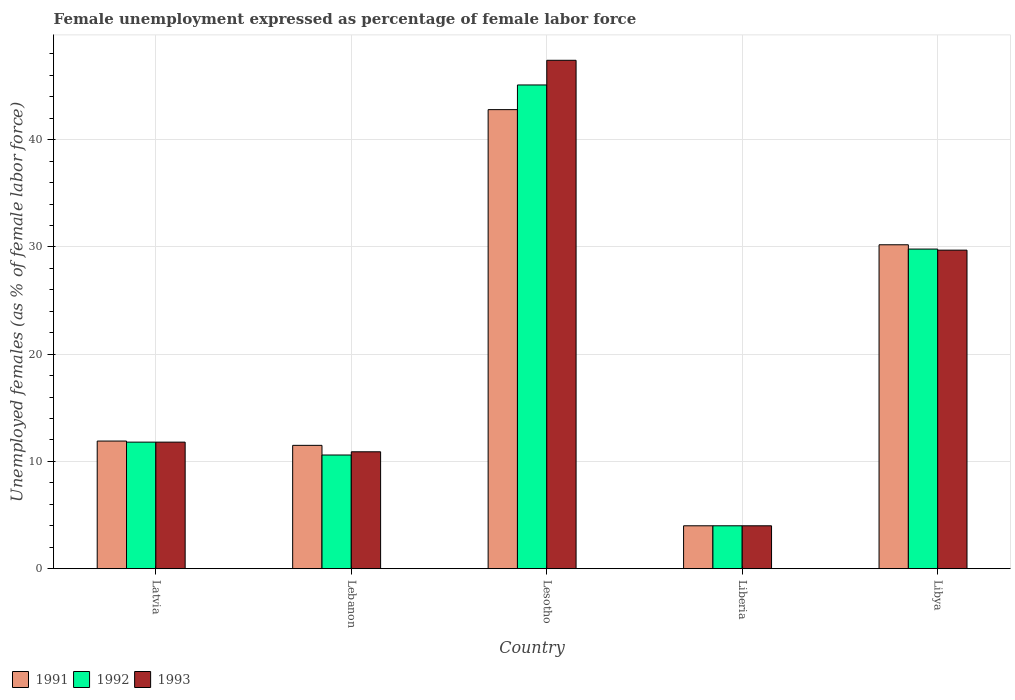How many different coloured bars are there?
Keep it short and to the point. 3. How many groups of bars are there?
Provide a succinct answer. 5. Are the number of bars per tick equal to the number of legend labels?
Your answer should be very brief. Yes. Are the number of bars on each tick of the X-axis equal?
Keep it short and to the point. Yes. How many bars are there on the 2nd tick from the right?
Keep it short and to the point. 3. What is the label of the 2nd group of bars from the left?
Offer a terse response. Lebanon. In how many cases, is the number of bars for a given country not equal to the number of legend labels?
Keep it short and to the point. 0. Across all countries, what is the maximum unemployment in females in in 1993?
Keep it short and to the point. 47.4. In which country was the unemployment in females in in 1991 maximum?
Provide a short and direct response. Lesotho. In which country was the unemployment in females in in 1991 minimum?
Offer a terse response. Liberia. What is the total unemployment in females in in 1992 in the graph?
Your answer should be very brief. 101.3. What is the difference between the unemployment in females in in 1992 in Latvia and that in Liberia?
Make the answer very short. 7.8. What is the difference between the unemployment in females in in 1993 in Lebanon and the unemployment in females in in 1992 in Latvia?
Give a very brief answer. -0.9. What is the average unemployment in females in in 1993 per country?
Your response must be concise. 20.76. In how many countries, is the unemployment in females in in 1991 greater than 18 %?
Provide a short and direct response. 2. What is the ratio of the unemployment in females in in 1993 in Latvia to that in Liberia?
Make the answer very short. 2.95. Is the unemployment in females in in 1993 in Latvia less than that in Liberia?
Your response must be concise. No. What is the difference between the highest and the second highest unemployment in females in in 1993?
Make the answer very short. -17.9. What is the difference between the highest and the lowest unemployment in females in in 1993?
Offer a terse response. 43.4. In how many countries, is the unemployment in females in in 1993 greater than the average unemployment in females in in 1993 taken over all countries?
Offer a terse response. 2. Is the sum of the unemployment in females in in 1992 in Latvia and Libya greater than the maximum unemployment in females in in 1991 across all countries?
Provide a succinct answer. No. What does the 1st bar from the left in Libya represents?
Offer a very short reply. 1991. What does the 3rd bar from the right in Lebanon represents?
Keep it short and to the point. 1991. Is it the case that in every country, the sum of the unemployment in females in in 1991 and unemployment in females in in 1992 is greater than the unemployment in females in in 1993?
Your answer should be very brief. Yes. How many bars are there?
Your answer should be very brief. 15. Are all the bars in the graph horizontal?
Ensure brevity in your answer.  No. How many countries are there in the graph?
Give a very brief answer. 5. Does the graph contain any zero values?
Your answer should be very brief. No. How are the legend labels stacked?
Your answer should be compact. Horizontal. What is the title of the graph?
Give a very brief answer. Female unemployment expressed as percentage of female labor force. What is the label or title of the Y-axis?
Make the answer very short. Unemployed females (as % of female labor force). What is the Unemployed females (as % of female labor force) in 1991 in Latvia?
Make the answer very short. 11.9. What is the Unemployed females (as % of female labor force) of 1992 in Latvia?
Offer a very short reply. 11.8. What is the Unemployed females (as % of female labor force) in 1993 in Latvia?
Ensure brevity in your answer.  11.8. What is the Unemployed females (as % of female labor force) of 1992 in Lebanon?
Provide a succinct answer. 10.6. What is the Unemployed females (as % of female labor force) in 1993 in Lebanon?
Offer a very short reply. 10.9. What is the Unemployed females (as % of female labor force) of 1991 in Lesotho?
Ensure brevity in your answer.  42.8. What is the Unemployed females (as % of female labor force) of 1992 in Lesotho?
Provide a short and direct response. 45.1. What is the Unemployed females (as % of female labor force) in 1993 in Lesotho?
Ensure brevity in your answer.  47.4. What is the Unemployed females (as % of female labor force) in 1991 in Liberia?
Offer a terse response. 4. What is the Unemployed females (as % of female labor force) in 1992 in Liberia?
Offer a terse response. 4. What is the Unemployed females (as % of female labor force) of 1993 in Liberia?
Keep it short and to the point. 4. What is the Unemployed females (as % of female labor force) of 1991 in Libya?
Ensure brevity in your answer.  30.2. What is the Unemployed females (as % of female labor force) in 1992 in Libya?
Keep it short and to the point. 29.8. What is the Unemployed females (as % of female labor force) in 1993 in Libya?
Offer a very short reply. 29.7. Across all countries, what is the maximum Unemployed females (as % of female labor force) of 1991?
Provide a succinct answer. 42.8. Across all countries, what is the maximum Unemployed females (as % of female labor force) of 1992?
Give a very brief answer. 45.1. Across all countries, what is the maximum Unemployed females (as % of female labor force) of 1993?
Give a very brief answer. 47.4. Across all countries, what is the minimum Unemployed females (as % of female labor force) in 1991?
Your answer should be very brief. 4. Across all countries, what is the minimum Unemployed females (as % of female labor force) of 1992?
Your answer should be very brief. 4. What is the total Unemployed females (as % of female labor force) of 1991 in the graph?
Your answer should be very brief. 100.4. What is the total Unemployed females (as % of female labor force) of 1992 in the graph?
Make the answer very short. 101.3. What is the total Unemployed females (as % of female labor force) of 1993 in the graph?
Give a very brief answer. 103.8. What is the difference between the Unemployed females (as % of female labor force) in 1991 in Latvia and that in Lebanon?
Make the answer very short. 0.4. What is the difference between the Unemployed females (as % of female labor force) of 1992 in Latvia and that in Lebanon?
Provide a short and direct response. 1.2. What is the difference between the Unemployed females (as % of female labor force) of 1991 in Latvia and that in Lesotho?
Offer a terse response. -30.9. What is the difference between the Unemployed females (as % of female labor force) of 1992 in Latvia and that in Lesotho?
Keep it short and to the point. -33.3. What is the difference between the Unemployed females (as % of female labor force) in 1993 in Latvia and that in Lesotho?
Give a very brief answer. -35.6. What is the difference between the Unemployed females (as % of female labor force) in 1993 in Latvia and that in Liberia?
Make the answer very short. 7.8. What is the difference between the Unemployed females (as % of female labor force) of 1991 in Latvia and that in Libya?
Your answer should be compact. -18.3. What is the difference between the Unemployed females (as % of female labor force) in 1992 in Latvia and that in Libya?
Keep it short and to the point. -18. What is the difference between the Unemployed females (as % of female labor force) of 1993 in Latvia and that in Libya?
Provide a succinct answer. -17.9. What is the difference between the Unemployed females (as % of female labor force) in 1991 in Lebanon and that in Lesotho?
Ensure brevity in your answer.  -31.3. What is the difference between the Unemployed females (as % of female labor force) of 1992 in Lebanon and that in Lesotho?
Provide a short and direct response. -34.5. What is the difference between the Unemployed females (as % of female labor force) of 1993 in Lebanon and that in Lesotho?
Offer a very short reply. -36.5. What is the difference between the Unemployed females (as % of female labor force) in 1993 in Lebanon and that in Liberia?
Your response must be concise. 6.9. What is the difference between the Unemployed females (as % of female labor force) of 1991 in Lebanon and that in Libya?
Provide a short and direct response. -18.7. What is the difference between the Unemployed females (as % of female labor force) in 1992 in Lebanon and that in Libya?
Provide a succinct answer. -19.2. What is the difference between the Unemployed females (as % of female labor force) in 1993 in Lebanon and that in Libya?
Provide a short and direct response. -18.8. What is the difference between the Unemployed females (as % of female labor force) in 1991 in Lesotho and that in Liberia?
Provide a short and direct response. 38.8. What is the difference between the Unemployed females (as % of female labor force) of 1992 in Lesotho and that in Liberia?
Offer a very short reply. 41.1. What is the difference between the Unemployed females (as % of female labor force) of 1993 in Lesotho and that in Liberia?
Ensure brevity in your answer.  43.4. What is the difference between the Unemployed females (as % of female labor force) in 1991 in Lesotho and that in Libya?
Your response must be concise. 12.6. What is the difference between the Unemployed females (as % of female labor force) of 1993 in Lesotho and that in Libya?
Ensure brevity in your answer.  17.7. What is the difference between the Unemployed females (as % of female labor force) in 1991 in Liberia and that in Libya?
Give a very brief answer. -26.2. What is the difference between the Unemployed females (as % of female labor force) in 1992 in Liberia and that in Libya?
Give a very brief answer. -25.8. What is the difference between the Unemployed females (as % of female labor force) in 1993 in Liberia and that in Libya?
Your response must be concise. -25.7. What is the difference between the Unemployed females (as % of female labor force) in 1992 in Latvia and the Unemployed females (as % of female labor force) in 1993 in Lebanon?
Your response must be concise. 0.9. What is the difference between the Unemployed females (as % of female labor force) of 1991 in Latvia and the Unemployed females (as % of female labor force) of 1992 in Lesotho?
Offer a very short reply. -33.2. What is the difference between the Unemployed females (as % of female labor force) of 1991 in Latvia and the Unemployed females (as % of female labor force) of 1993 in Lesotho?
Your answer should be very brief. -35.5. What is the difference between the Unemployed females (as % of female labor force) in 1992 in Latvia and the Unemployed females (as % of female labor force) in 1993 in Lesotho?
Your answer should be very brief. -35.6. What is the difference between the Unemployed females (as % of female labor force) of 1991 in Latvia and the Unemployed females (as % of female labor force) of 1993 in Liberia?
Offer a terse response. 7.9. What is the difference between the Unemployed females (as % of female labor force) in 1991 in Latvia and the Unemployed females (as % of female labor force) in 1992 in Libya?
Make the answer very short. -17.9. What is the difference between the Unemployed females (as % of female labor force) in 1991 in Latvia and the Unemployed females (as % of female labor force) in 1993 in Libya?
Your response must be concise. -17.8. What is the difference between the Unemployed females (as % of female labor force) in 1992 in Latvia and the Unemployed females (as % of female labor force) in 1993 in Libya?
Make the answer very short. -17.9. What is the difference between the Unemployed females (as % of female labor force) in 1991 in Lebanon and the Unemployed females (as % of female labor force) in 1992 in Lesotho?
Make the answer very short. -33.6. What is the difference between the Unemployed females (as % of female labor force) in 1991 in Lebanon and the Unemployed females (as % of female labor force) in 1993 in Lesotho?
Offer a terse response. -35.9. What is the difference between the Unemployed females (as % of female labor force) of 1992 in Lebanon and the Unemployed females (as % of female labor force) of 1993 in Lesotho?
Offer a terse response. -36.8. What is the difference between the Unemployed females (as % of female labor force) in 1991 in Lebanon and the Unemployed females (as % of female labor force) in 1992 in Liberia?
Ensure brevity in your answer.  7.5. What is the difference between the Unemployed females (as % of female labor force) of 1991 in Lebanon and the Unemployed females (as % of female labor force) of 1993 in Liberia?
Make the answer very short. 7.5. What is the difference between the Unemployed females (as % of female labor force) of 1991 in Lebanon and the Unemployed females (as % of female labor force) of 1992 in Libya?
Provide a short and direct response. -18.3. What is the difference between the Unemployed females (as % of female labor force) of 1991 in Lebanon and the Unemployed females (as % of female labor force) of 1993 in Libya?
Keep it short and to the point. -18.2. What is the difference between the Unemployed females (as % of female labor force) of 1992 in Lebanon and the Unemployed females (as % of female labor force) of 1993 in Libya?
Your answer should be very brief. -19.1. What is the difference between the Unemployed females (as % of female labor force) in 1991 in Lesotho and the Unemployed females (as % of female labor force) in 1992 in Liberia?
Give a very brief answer. 38.8. What is the difference between the Unemployed females (as % of female labor force) in 1991 in Lesotho and the Unemployed females (as % of female labor force) in 1993 in Liberia?
Make the answer very short. 38.8. What is the difference between the Unemployed females (as % of female labor force) of 1992 in Lesotho and the Unemployed females (as % of female labor force) of 1993 in Liberia?
Offer a very short reply. 41.1. What is the difference between the Unemployed females (as % of female labor force) in 1991 in Lesotho and the Unemployed females (as % of female labor force) in 1993 in Libya?
Provide a short and direct response. 13.1. What is the difference between the Unemployed females (as % of female labor force) in 1992 in Lesotho and the Unemployed females (as % of female labor force) in 1993 in Libya?
Your answer should be compact. 15.4. What is the difference between the Unemployed females (as % of female labor force) in 1991 in Liberia and the Unemployed females (as % of female labor force) in 1992 in Libya?
Provide a short and direct response. -25.8. What is the difference between the Unemployed females (as % of female labor force) in 1991 in Liberia and the Unemployed females (as % of female labor force) in 1993 in Libya?
Ensure brevity in your answer.  -25.7. What is the difference between the Unemployed females (as % of female labor force) in 1992 in Liberia and the Unemployed females (as % of female labor force) in 1993 in Libya?
Ensure brevity in your answer.  -25.7. What is the average Unemployed females (as % of female labor force) in 1991 per country?
Provide a succinct answer. 20.08. What is the average Unemployed females (as % of female labor force) in 1992 per country?
Offer a very short reply. 20.26. What is the average Unemployed females (as % of female labor force) of 1993 per country?
Offer a very short reply. 20.76. What is the difference between the Unemployed females (as % of female labor force) in 1991 and Unemployed females (as % of female labor force) in 1992 in Latvia?
Offer a very short reply. 0.1. What is the difference between the Unemployed females (as % of female labor force) of 1992 and Unemployed females (as % of female labor force) of 1993 in Latvia?
Offer a terse response. 0. What is the difference between the Unemployed females (as % of female labor force) of 1991 and Unemployed females (as % of female labor force) of 1992 in Lebanon?
Offer a terse response. 0.9. What is the difference between the Unemployed females (as % of female labor force) in 1991 and Unemployed females (as % of female labor force) in 1993 in Lebanon?
Offer a terse response. 0.6. What is the difference between the Unemployed females (as % of female labor force) in 1991 and Unemployed females (as % of female labor force) in 1992 in Lesotho?
Your response must be concise. -2.3. What is the difference between the Unemployed females (as % of female labor force) of 1992 and Unemployed females (as % of female labor force) of 1993 in Lesotho?
Keep it short and to the point. -2.3. What is the difference between the Unemployed females (as % of female labor force) of 1991 and Unemployed females (as % of female labor force) of 1992 in Liberia?
Provide a short and direct response. 0. What is the difference between the Unemployed females (as % of female labor force) of 1991 and Unemployed females (as % of female labor force) of 1993 in Liberia?
Offer a very short reply. 0. What is the difference between the Unemployed females (as % of female labor force) of 1992 and Unemployed females (as % of female labor force) of 1993 in Liberia?
Keep it short and to the point. 0. What is the difference between the Unemployed females (as % of female labor force) in 1991 and Unemployed females (as % of female labor force) in 1992 in Libya?
Ensure brevity in your answer.  0.4. What is the difference between the Unemployed females (as % of female labor force) in 1991 and Unemployed females (as % of female labor force) in 1993 in Libya?
Make the answer very short. 0.5. What is the difference between the Unemployed females (as % of female labor force) in 1992 and Unemployed females (as % of female labor force) in 1993 in Libya?
Your answer should be compact. 0.1. What is the ratio of the Unemployed females (as % of female labor force) in 1991 in Latvia to that in Lebanon?
Keep it short and to the point. 1.03. What is the ratio of the Unemployed females (as % of female labor force) in 1992 in Latvia to that in Lebanon?
Ensure brevity in your answer.  1.11. What is the ratio of the Unemployed females (as % of female labor force) in 1993 in Latvia to that in Lebanon?
Provide a short and direct response. 1.08. What is the ratio of the Unemployed females (as % of female labor force) of 1991 in Latvia to that in Lesotho?
Provide a short and direct response. 0.28. What is the ratio of the Unemployed females (as % of female labor force) in 1992 in Latvia to that in Lesotho?
Make the answer very short. 0.26. What is the ratio of the Unemployed females (as % of female labor force) of 1993 in Latvia to that in Lesotho?
Ensure brevity in your answer.  0.25. What is the ratio of the Unemployed females (as % of female labor force) in 1991 in Latvia to that in Liberia?
Your response must be concise. 2.98. What is the ratio of the Unemployed females (as % of female labor force) in 1992 in Latvia to that in Liberia?
Give a very brief answer. 2.95. What is the ratio of the Unemployed females (as % of female labor force) in 1993 in Latvia to that in Liberia?
Provide a short and direct response. 2.95. What is the ratio of the Unemployed females (as % of female labor force) in 1991 in Latvia to that in Libya?
Offer a terse response. 0.39. What is the ratio of the Unemployed females (as % of female labor force) of 1992 in Latvia to that in Libya?
Make the answer very short. 0.4. What is the ratio of the Unemployed females (as % of female labor force) in 1993 in Latvia to that in Libya?
Your answer should be compact. 0.4. What is the ratio of the Unemployed females (as % of female labor force) in 1991 in Lebanon to that in Lesotho?
Your answer should be compact. 0.27. What is the ratio of the Unemployed females (as % of female labor force) in 1992 in Lebanon to that in Lesotho?
Offer a very short reply. 0.23. What is the ratio of the Unemployed females (as % of female labor force) of 1993 in Lebanon to that in Lesotho?
Provide a succinct answer. 0.23. What is the ratio of the Unemployed females (as % of female labor force) in 1991 in Lebanon to that in Liberia?
Give a very brief answer. 2.88. What is the ratio of the Unemployed females (as % of female labor force) in 1992 in Lebanon to that in Liberia?
Your answer should be very brief. 2.65. What is the ratio of the Unemployed females (as % of female labor force) in 1993 in Lebanon to that in Liberia?
Offer a very short reply. 2.73. What is the ratio of the Unemployed females (as % of female labor force) of 1991 in Lebanon to that in Libya?
Provide a short and direct response. 0.38. What is the ratio of the Unemployed females (as % of female labor force) of 1992 in Lebanon to that in Libya?
Your response must be concise. 0.36. What is the ratio of the Unemployed females (as % of female labor force) in 1993 in Lebanon to that in Libya?
Give a very brief answer. 0.37. What is the ratio of the Unemployed females (as % of female labor force) in 1991 in Lesotho to that in Liberia?
Give a very brief answer. 10.7. What is the ratio of the Unemployed females (as % of female labor force) in 1992 in Lesotho to that in Liberia?
Provide a succinct answer. 11.28. What is the ratio of the Unemployed females (as % of female labor force) of 1993 in Lesotho to that in Liberia?
Give a very brief answer. 11.85. What is the ratio of the Unemployed females (as % of female labor force) in 1991 in Lesotho to that in Libya?
Provide a succinct answer. 1.42. What is the ratio of the Unemployed females (as % of female labor force) of 1992 in Lesotho to that in Libya?
Make the answer very short. 1.51. What is the ratio of the Unemployed females (as % of female labor force) in 1993 in Lesotho to that in Libya?
Provide a succinct answer. 1.6. What is the ratio of the Unemployed females (as % of female labor force) of 1991 in Liberia to that in Libya?
Offer a very short reply. 0.13. What is the ratio of the Unemployed females (as % of female labor force) in 1992 in Liberia to that in Libya?
Give a very brief answer. 0.13. What is the ratio of the Unemployed females (as % of female labor force) of 1993 in Liberia to that in Libya?
Your answer should be compact. 0.13. What is the difference between the highest and the second highest Unemployed females (as % of female labor force) in 1992?
Your answer should be very brief. 15.3. What is the difference between the highest and the lowest Unemployed females (as % of female labor force) of 1991?
Keep it short and to the point. 38.8. What is the difference between the highest and the lowest Unemployed females (as % of female labor force) of 1992?
Offer a terse response. 41.1. What is the difference between the highest and the lowest Unemployed females (as % of female labor force) in 1993?
Keep it short and to the point. 43.4. 